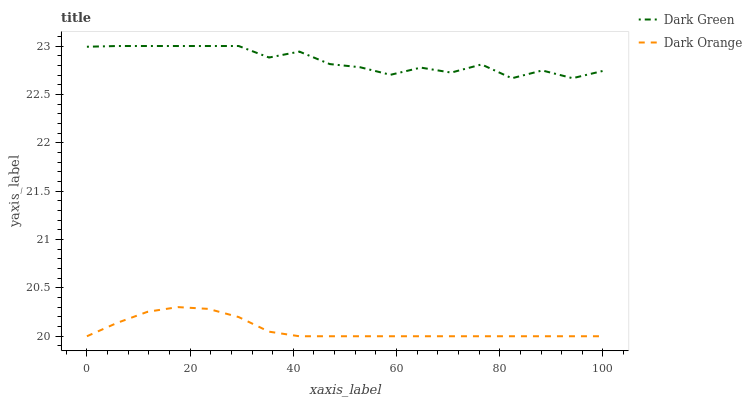Does Dark Orange have the minimum area under the curve?
Answer yes or no. Yes. Does Dark Green have the maximum area under the curve?
Answer yes or no. Yes. Does Dark Green have the minimum area under the curve?
Answer yes or no. No. Is Dark Orange the smoothest?
Answer yes or no. Yes. Is Dark Green the roughest?
Answer yes or no. Yes. Is Dark Green the smoothest?
Answer yes or no. No. Does Dark Orange have the lowest value?
Answer yes or no. Yes. Does Dark Green have the lowest value?
Answer yes or no. No. Does Dark Green have the highest value?
Answer yes or no. Yes. Is Dark Orange less than Dark Green?
Answer yes or no. Yes. Is Dark Green greater than Dark Orange?
Answer yes or no. Yes. Does Dark Orange intersect Dark Green?
Answer yes or no. No. 